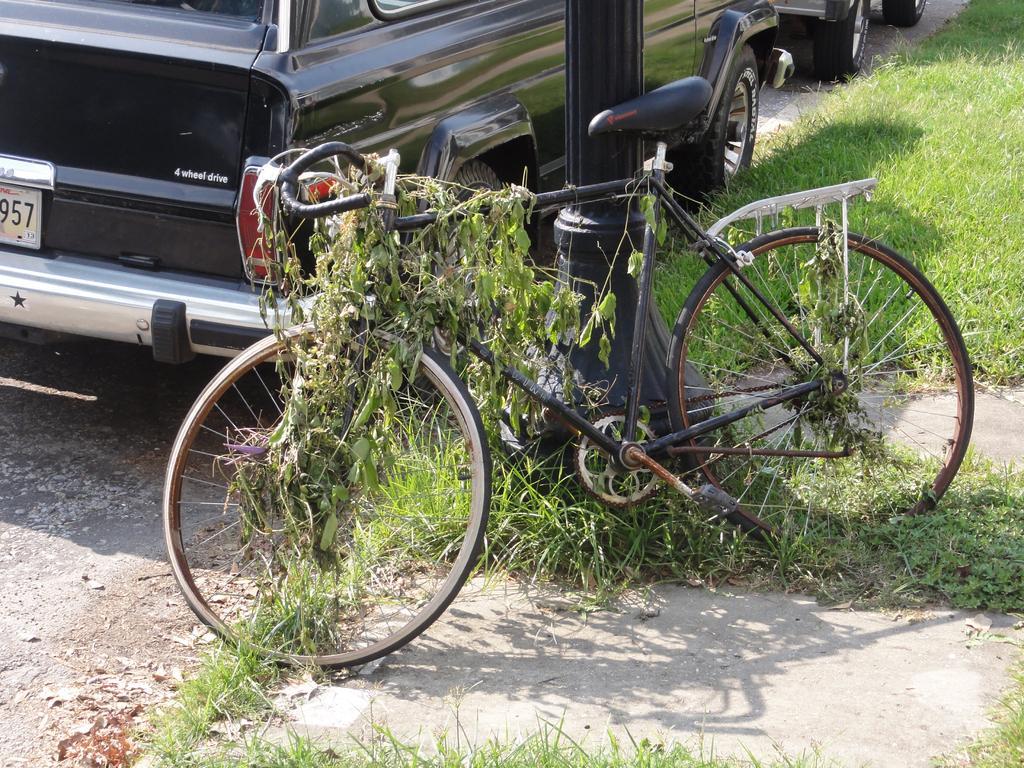How would you summarize this image in a sentence or two? In this image I can see the bicycle to the side of the pole. On the bicycle I can see the leaves of the plant. In the back I can see the vehicles on the ground. To the side of the vehicles I can see the grass. 